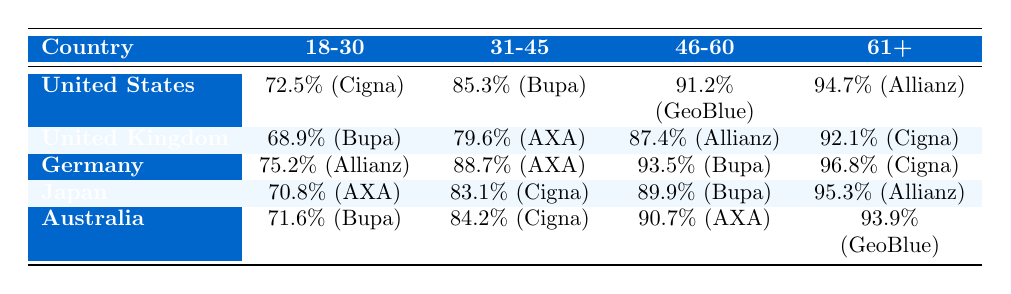What is the highest coverage rate for the age group 61+ among the countries listed? Looking at the table, Germany has a coverage rate of 96.8% for the age group 61+, which is the highest compared to the other countries.
Answer: 96.8% Which country has the lowest coverage rate for the age group 18-30? The table shows that the United Kingdom has the lowest coverage rate of 68.9% for the age group 18-30 compared to the other countries.
Answer: 68.9% What is the average coverage rate for the age group 31-45 across all countries? Adding the coverage rates for the 31-45 age group: 85.3 (US) + 79.6 (UK) + 88.7 (Germany) + 83.1 (Japan) + 84.2 (Australia) = 421.9. There are 5 countries, so the average is 421.9 / 5 = 84.38.
Answer: 84.38% Is the top provider for the age group 46-60 the same in both the United States and Australia? In the United States, the top provider for 46-60 is GeoBlue, while in Australia it is AXA International. Since the providers differ, the answer is no.
Answer: No What is the difference in coverage rates for the 61+ age group between the United States and Japan? The coverage rate for the United States is 94.7% and for Japan it is 95.3%. The difference is 95.3 - 94.7 = 0.6%.
Answer: 0.6% Which age group in Germany has the highest coverage rate, and what is that rate? In Germany, the age group 61+ has the highest coverage rate at 96.8%, as indicated in the table when comparing the rates across all age groups.
Answer: 96.8% For the age group 31-45, which country has the highest coverage rate, and what is that coverage rate? The table indicates that Germany has the highest coverage rate of 88.7% for the age group 31-45 compared to the other countries listed.
Answer: 88.7% Is the coverage rate for the age group 18-30 in Japan higher than that in Australia? The coverage rate in Japan is 70.8% while in Australia it is 71.6%. Since 70.8% is less than 71.6%, the statement is false.
Answer: No What is the trend in coverage rates from the age group 18-30 to 61+ in the United States? In the United States, the coverage rates increase from 72.5% (18-30) to 85.3% (31-45) to 91.2% (46-60) and finally to 94.7% (61+), indicating a clear upward trend in coverage rates across these age groups.
Answer: Upward trend Which country's top provider for age group 61+ has the same name as a country in Europe? The top provider for the age group 61+ in the United Kingdom is Cigna Global, which has the same name as the country of Cigna. However, Cigna is not a country, thus no.
Answer: No 